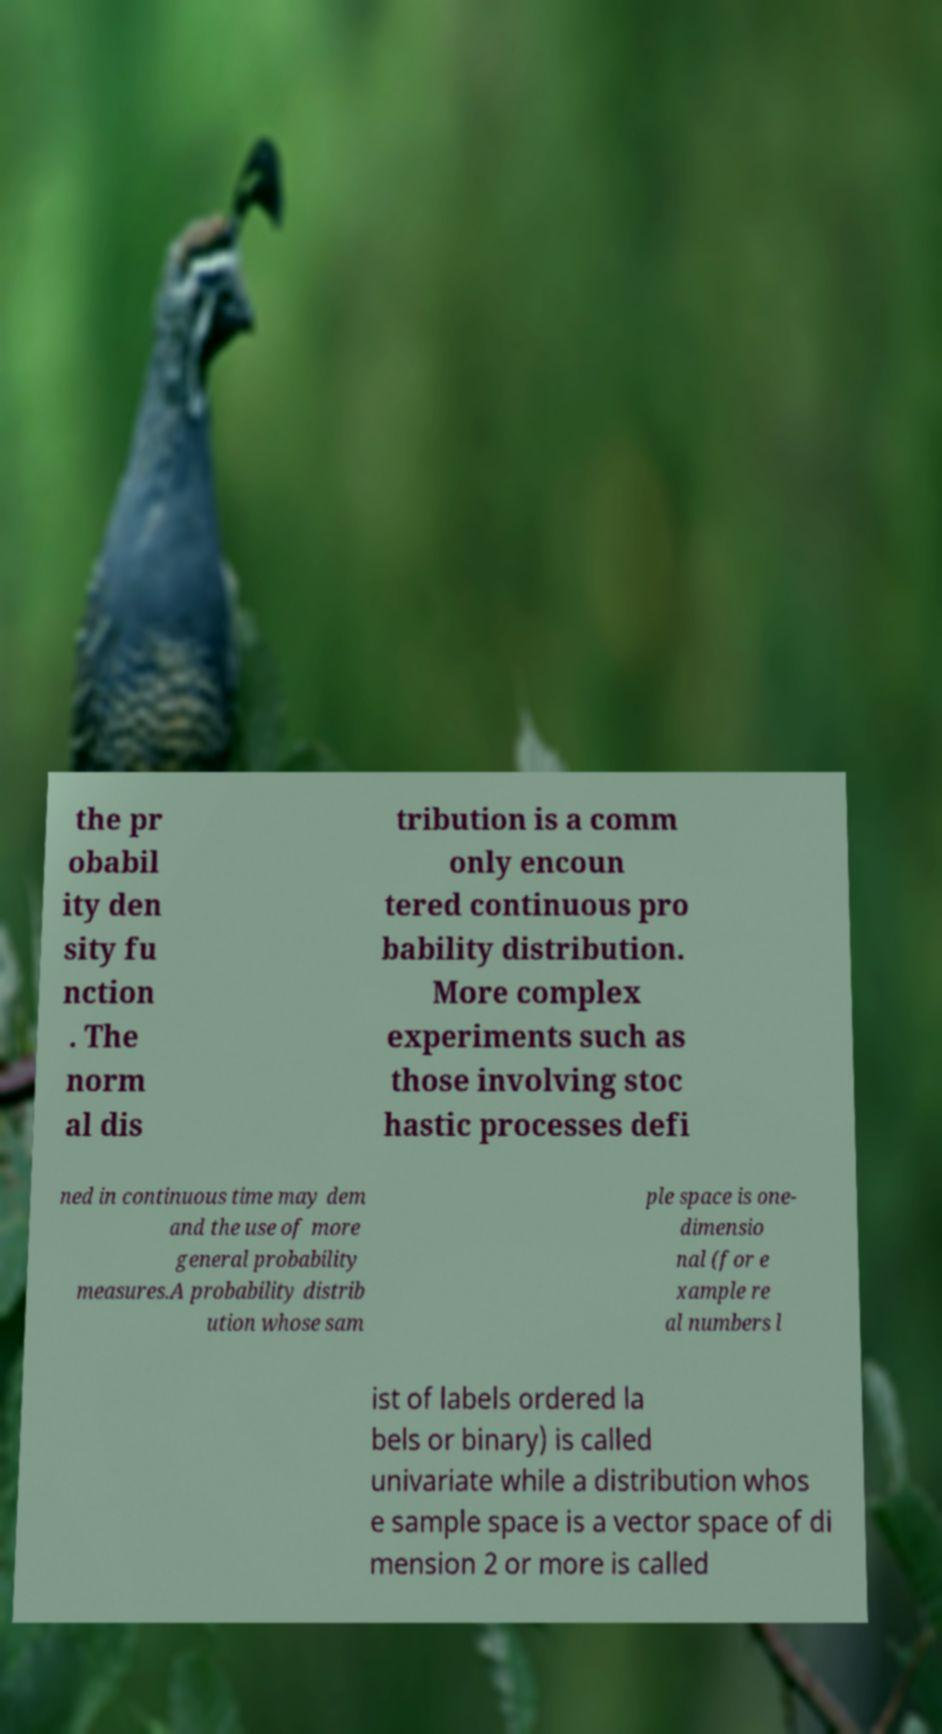I need the written content from this picture converted into text. Can you do that? the pr obabil ity den sity fu nction . The norm al dis tribution is a comm only encoun tered continuous pro bability distribution. More complex experiments such as those involving stoc hastic processes defi ned in continuous time may dem and the use of more general probability measures.A probability distrib ution whose sam ple space is one- dimensio nal (for e xample re al numbers l ist of labels ordered la bels or binary) is called univariate while a distribution whos e sample space is a vector space of di mension 2 or more is called 